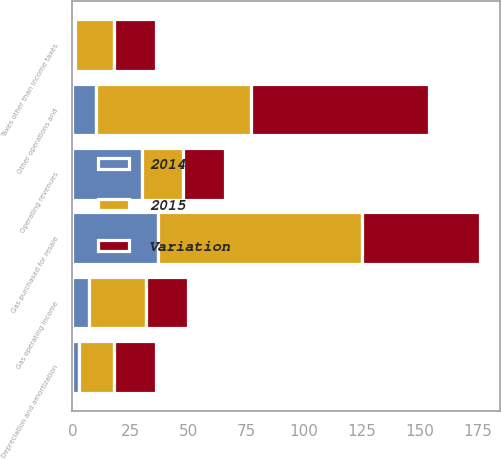Convert chart. <chart><loc_0><loc_0><loc_500><loc_500><stacked_bar_chart><ecel><fcel>Operating revenues<fcel>Gas purchased for resale<fcel>Other operations and<fcel>Depreciation and amortization<fcel>Taxes other than income taxes<fcel>Gas operating income<nl><fcel>Variation<fcel>18<fcel>51<fcel>77<fcel>18<fcel>18<fcel>18<nl><fcel>2015<fcel>18<fcel>88<fcel>67<fcel>15<fcel>17<fcel>25<nl><fcel>2014<fcel>30<fcel>37<fcel>10<fcel>3<fcel>1<fcel>7<nl></chart> 